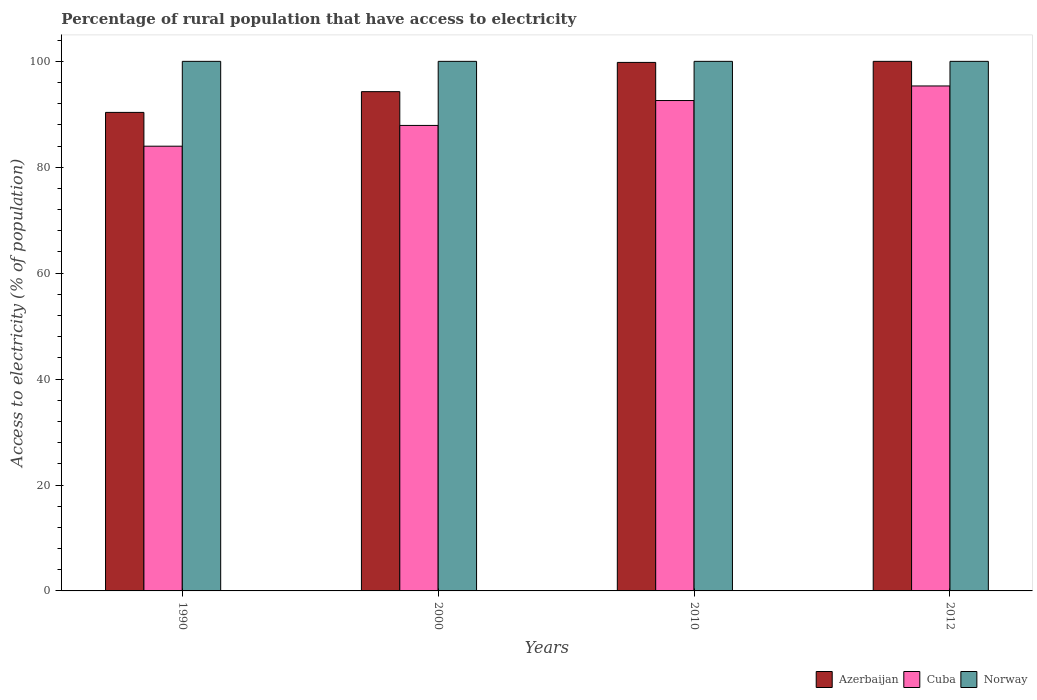How many groups of bars are there?
Offer a terse response. 4. Are the number of bars per tick equal to the number of legend labels?
Keep it short and to the point. Yes. What is the percentage of rural population that have access to electricity in Azerbaijan in 2012?
Ensure brevity in your answer.  100. Across all years, what is the maximum percentage of rural population that have access to electricity in Norway?
Make the answer very short. 100. Across all years, what is the minimum percentage of rural population that have access to electricity in Cuba?
Give a very brief answer. 83.98. In which year was the percentage of rural population that have access to electricity in Norway minimum?
Offer a terse response. 1990. What is the total percentage of rural population that have access to electricity in Cuba in the graph?
Your response must be concise. 359.83. What is the difference between the percentage of rural population that have access to electricity in Azerbaijan in 1990 and that in 2010?
Your answer should be very brief. -9.44. What is the difference between the percentage of rural population that have access to electricity in Cuba in 2010 and the percentage of rural population that have access to electricity in Norway in 2012?
Give a very brief answer. -7.4. What is the average percentage of rural population that have access to electricity in Norway per year?
Offer a terse response. 100. In the year 2010, what is the difference between the percentage of rural population that have access to electricity in Cuba and percentage of rural population that have access to electricity in Norway?
Your response must be concise. -7.4. In how many years, is the percentage of rural population that have access to electricity in Norway greater than 72 %?
Provide a succinct answer. 4. What is the ratio of the percentage of rural population that have access to electricity in Azerbaijan in 1990 to that in 2012?
Keep it short and to the point. 0.9. Is the percentage of rural population that have access to electricity in Norway in 1990 less than that in 2000?
Keep it short and to the point. No. Is the difference between the percentage of rural population that have access to electricity in Cuba in 2000 and 2012 greater than the difference between the percentage of rural population that have access to electricity in Norway in 2000 and 2012?
Your response must be concise. No. What is the difference between the highest and the second highest percentage of rural population that have access to electricity in Norway?
Make the answer very short. 0. What is the difference between the highest and the lowest percentage of rural population that have access to electricity in Azerbaijan?
Your response must be concise. 9.64. In how many years, is the percentage of rural population that have access to electricity in Cuba greater than the average percentage of rural population that have access to electricity in Cuba taken over all years?
Provide a short and direct response. 2. What does the 2nd bar from the left in 2012 represents?
Your answer should be very brief. Cuba. How many bars are there?
Your answer should be very brief. 12. Are all the bars in the graph horizontal?
Your answer should be very brief. No. What is the difference between two consecutive major ticks on the Y-axis?
Make the answer very short. 20. Are the values on the major ticks of Y-axis written in scientific E-notation?
Ensure brevity in your answer.  No. Does the graph contain grids?
Your response must be concise. No. Where does the legend appear in the graph?
Give a very brief answer. Bottom right. How many legend labels are there?
Offer a terse response. 3. How are the legend labels stacked?
Offer a very short reply. Horizontal. What is the title of the graph?
Offer a very short reply. Percentage of rural population that have access to electricity. Does "Denmark" appear as one of the legend labels in the graph?
Ensure brevity in your answer.  No. What is the label or title of the X-axis?
Offer a terse response. Years. What is the label or title of the Y-axis?
Keep it short and to the point. Access to electricity (% of population). What is the Access to electricity (% of population) of Azerbaijan in 1990?
Ensure brevity in your answer.  90.36. What is the Access to electricity (% of population) of Cuba in 1990?
Keep it short and to the point. 83.98. What is the Access to electricity (% of population) in Norway in 1990?
Provide a short and direct response. 100. What is the Access to electricity (% of population) of Azerbaijan in 2000?
Keep it short and to the point. 94.28. What is the Access to electricity (% of population) of Cuba in 2000?
Your answer should be very brief. 87.9. What is the Access to electricity (% of population) in Azerbaijan in 2010?
Provide a short and direct response. 99.8. What is the Access to electricity (% of population) in Cuba in 2010?
Your answer should be very brief. 92.6. What is the Access to electricity (% of population) of Azerbaijan in 2012?
Provide a succinct answer. 100. What is the Access to electricity (% of population) of Cuba in 2012?
Ensure brevity in your answer.  95.35. What is the Access to electricity (% of population) in Norway in 2012?
Offer a terse response. 100. Across all years, what is the maximum Access to electricity (% of population) of Cuba?
Keep it short and to the point. 95.35. Across all years, what is the minimum Access to electricity (% of population) in Azerbaijan?
Keep it short and to the point. 90.36. Across all years, what is the minimum Access to electricity (% of population) of Cuba?
Offer a terse response. 83.98. What is the total Access to electricity (% of population) in Azerbaijan in the graph?
Your answer should be compact. 384.44. What is the total Access to electricity (% of population) in Cuba in the graph?
Your response must be concise. 359.83. What is the difference between the Access to electricity (% of population) of Azerbaijan in 1990 and that in 2000?
Your answer should be very brief. -3.92. What is the difference between the Access to electricity (% of population) in Cuba in 1990 and that in 2000?
Your answer should be compact. -3.92. What is the difference between the Access to electricity (% of population) in Norway in 1990 and that in 2000?
Make the answer very short. 0. What is the difference between the Access to electricity (% of population) of Azerbaijan in 1990 and that in 2010?
Offer a very short reply. -9.44. What is the difference between the Access to electricity (% of population) of Cuba in 1990 and that in 2010?
Offer a very short reply. -8.62. What is the difference between the Access to electricity (% of population) in Azerbaijan in 1990 and that in 2012?
Make the answer very short. -9.64. What is the difference between the Access to electricity (% of population) of Cuba in 1990 and that in 2012?
Your response must be concise. -11.38. What is the difference between the Access to electricity (% of population) in Norway in 1990 and that in 2012?
Make the answer very short. 0. What is the difference between the Access to electricity (% of population) in Azerbaijan in 2000 and that in 2010?
Give a very brief answer. -5.52. What is the difference between the Access to electricity (% of population) in Cuba in 2000 and that in 2010?
Your response must be concise. -4.7. What is the difference between the Access to electricity (% of population) of Norway in 2000 and that in 2010?
Give a very brief answer. 0. What is the difference between the Access to electricity (% of population) in Azerbaijan in 2000 and that in 2012?
Your response must be concise. -5.72. What is the difference between the Access to electricity (% of population) of Cuba in 2000 and that in 2012?
Your answer should be very brief. -7.45. What is the difference between the Access to electricity (% of population) of Norway in 2000 and that in 2012?
Make the answer very short. 0. What is the difference between the Access to electricity (% of population) in Cuba in 2010 and that in 2012?
Offer a terse response. -2.75. What is the difference between the Access to electricity (% of population) of Norway in 2010 and that in 2012?
Provide a succinct answer. 0. What is the difference between the Access to electricity (% of population) in Azerbaijan in 1990 and the Access to electricity (% of population) in Cuba in 2000?
Keep it short and to the point. 2.46. What is the difference between the Access to electricity (% of population) of Azerbaijan in 1990 and the Access to electricity (% of population) of Norway in 2000?
Offer a very short reply. -9.64. What is the difference between the Access to electricity (% of population) of Cuba in 1990 and the Access to electricity (% of population) of Norway in 2000?
Make the answer very short. -16.02. What is the difference between the Access to electricity (% of population) in Azerbaijan in 1990 and the Access to electricity (% of population) in Cuba in 2010?
Ensure brevity in your answer.  -2.24. What is the difference between the Access to electricity (% of population) of Azerbaijan in 1990 and the Access to electricity (% of population) of Norway in 2010?
Offer a very short reply. -9.64. What is the difference between the Access to electricity (% of population) of Cuba in 1990 and the Access to electricity (% of population) of Norway in 2010?
Make the answer very short. -16.02. What is the difference between the Access to electricity (% of population) of Azerbaijan in 1990 and the Access to electricity (% of population) of Cuba in 2012?
Offer a terse response. -4.99. What is the difference between the Access to electricity (% of population) in Azerbaijan in 1990 and the Access to electricity (% of population) in Norway in 2012?
Your response must be concise. -9.64. What is the difference between the Access to electricity (% of population) in Cuba in 1990 and the Access to electricity (% of population) in Norway in 2012?
Provide a short and direct response. -16.02. What is the difference between the Access to electricity (% of population) of Azerbaijan in 2000 and the Access to electricity (% of population) of Cuba in 2010?
Give a very brief answer. 1.68. What is the difference between the Access to electricity (% of population) in Azerbaijan in 2000 and the Access to electricity (% of population) in Norway in 2010?
Make the answer very short. -5.72. What is the difference between the Access to electricity (% of population) of Cuba in 2000 and the Access to electricity (% of population) of Norway in 2010?
Your response must be concise. -12.1. What is the difference between the Access to electricity (% of population) of Azerbaijan in 2000 and the Access to electricity (% of population) of Cuba in 2012?
Your response must be concise. -1.07. What is the difference between the Access to electricity (% of population) of Azerbaijan in 2000 and the Access to electricity (% of population) of Norway in 2012?
Keep it short and to the point. -5.72. What is the difference between the Access to electricity (% of population) of Cuba in 2000 and the Access to electricity (% of population) of Norway in 2012?
Offer a very short reply. -12.1. What is the difference between the Access to electricity (% of population) in Azerbaijan in 2010 and the Access to electricity (% of population) in Cuba in 2012?
Ensure brevity in your answer.  4.45. What is the difference between the Access to electricity (% of population) in Azerbaijan in 2010 and the Access to electricity (% of population) in Norway in 2012?
Ensure brevity in your answer.  -0.2. What is the difference between the Access to electricity (% of population) in Cuba in 2010 and the Access to electricity (% of population) in Norway in 2012?
Your response must be concise. -7.4. What is the average Access to electricity (% of population) in Azerbaijan per year?
Give a very brief answer. 96.11. What is the average Access to electricity (% of population) of Cuba per year?
Keep it short and to the point. 89.96. In the year 1990, what is the difference between the Access to electricity (% of population) of Azerbaijan and Access to electricity (% of population) of Cuba?
Make the answer very short. 6.38. In the year 1990, what is the difference between the Access to electricity (% of population) in Azerbaijan and Access to electricity (% of population) in Norway?
Your answer should be compact. -9.64. In the year 1990, what is the difference between the Access to electricity (% of population) of Cuba and Access to electricity (% of population) of Norway?
Give a very brief answer. -16.02. In the year 2000, what is the difference between the Access to electricity (% of population) in Azerbaijan and Access to electricity (% of population) in Cuba?
Offer a very short reply. 6.38. In the year 2000, what is the difference between the Access to electricity (% of population) in Azerbaijan and Access to electricity (% of population) in Norway?
Give a very brief answer. -5.72. In the year 2000, what is the difference between the Access to electricity (% of population) of Cuba and Access to electricity (% of population) of Norway?
Offer a very short reply. -12.1. In the year 2010, what is the difference between the Access to electricity (% of population) of Azerbaijan and Access to electricity (% of population) of Norway?
Give a very brief answer. -0.2. In the year 2012, what is the difference between the Access to electricity (% of population) in Azerbaijan and Access to electricity (% of population) in Cuba?
Keep it short and to the point. 4.65. In the year 2012, what is the difference between the Access to electricity (% of population) of Cuba and Access to electricity (% of population) of Norway?
Provide a succinct answer. -4.65. What is the ratio of the Access to electricity (% of population) in Azerbaijan in 1990 to that in 2000?
Ensure brevity in your answer.  0.96. What is the ratio of the Access to electricity (% of population) of Cuba in 1990 to that in 2000?
Your answer should be very brief. 0.96. What is the ratio of the Access to electricity (% of population) in Azerbaijan in 1990 to that in 2010?
Give a very brief answer. 0.91. What is the ratio of the Access to electricity (% of population) of Cuba in 1990 to that in 2010?
Your response must be concise. 0.91. What is the ratio of the Access to electricity (% of population) in Norway in 1990 to that in 2010?
Provide a short and direct response. 1. What is the ratio of the Access to electricity (% of population) of Azerbaijan in 1990 to that in 2012?
Ensure brevity in your answer.  0.9. What is the ratio of the Access to electricity (% of population) of Cuba in 1990 to that in 2012?
Provide a succinct answer. 0.88. What is the ratio of the Access to electricity (% of population) in Azerbaijan in 2000 to that in 2010?
Your response must be concise. 0.94. What is the ratio of the Access to electricity (% of population) in Cuba in 2000 to that in 2010?
Offer a very short reply. 0.95. What is the ratio of the Access to electricity (% of population) of Norway in 2000 to that in 2010?
Make the answer very short. 1. What is the ratio of the Access to electricity (% of population) in Azerbaijan in 2000 to that in 2012?
Offer a very short reply. 0.94. What is the ratio of the Access to electricity (% of population) of Cuba in 2000 to that in 2012?
Make the answer very short. 0.92. What is the ratio of the Access to electricity (% of population) in Azerbaijan in 2010 to that in 2012?
Your answer should be very brief. 1. What is the ratio of the Access to electricity (% of population) in Cuba in 2010 to that in 2012?
Offer a terse response. 0.97. What is the ratio of the Access to electricity (% of population) in Norway in 2010 to that in 2012?
Your answer should be very brief. 1. What is the difference between the highest and the second highest Access to electricity (% of population) in Cuba?
Your response must be concise. 2.75. What is the difference between the highest and the lowest Access to electricity (% of population) of Azerbaijan?
Provide a short and direct response. 9.64. What is the difference between the highest and the lowest Access to electricity (% of population) of Cuba?
Your answer should be compact. 11.38. What is the difference between the highest and the lowest Access to electricity (% of population) in Norway?
Your response must be concise. 0. 